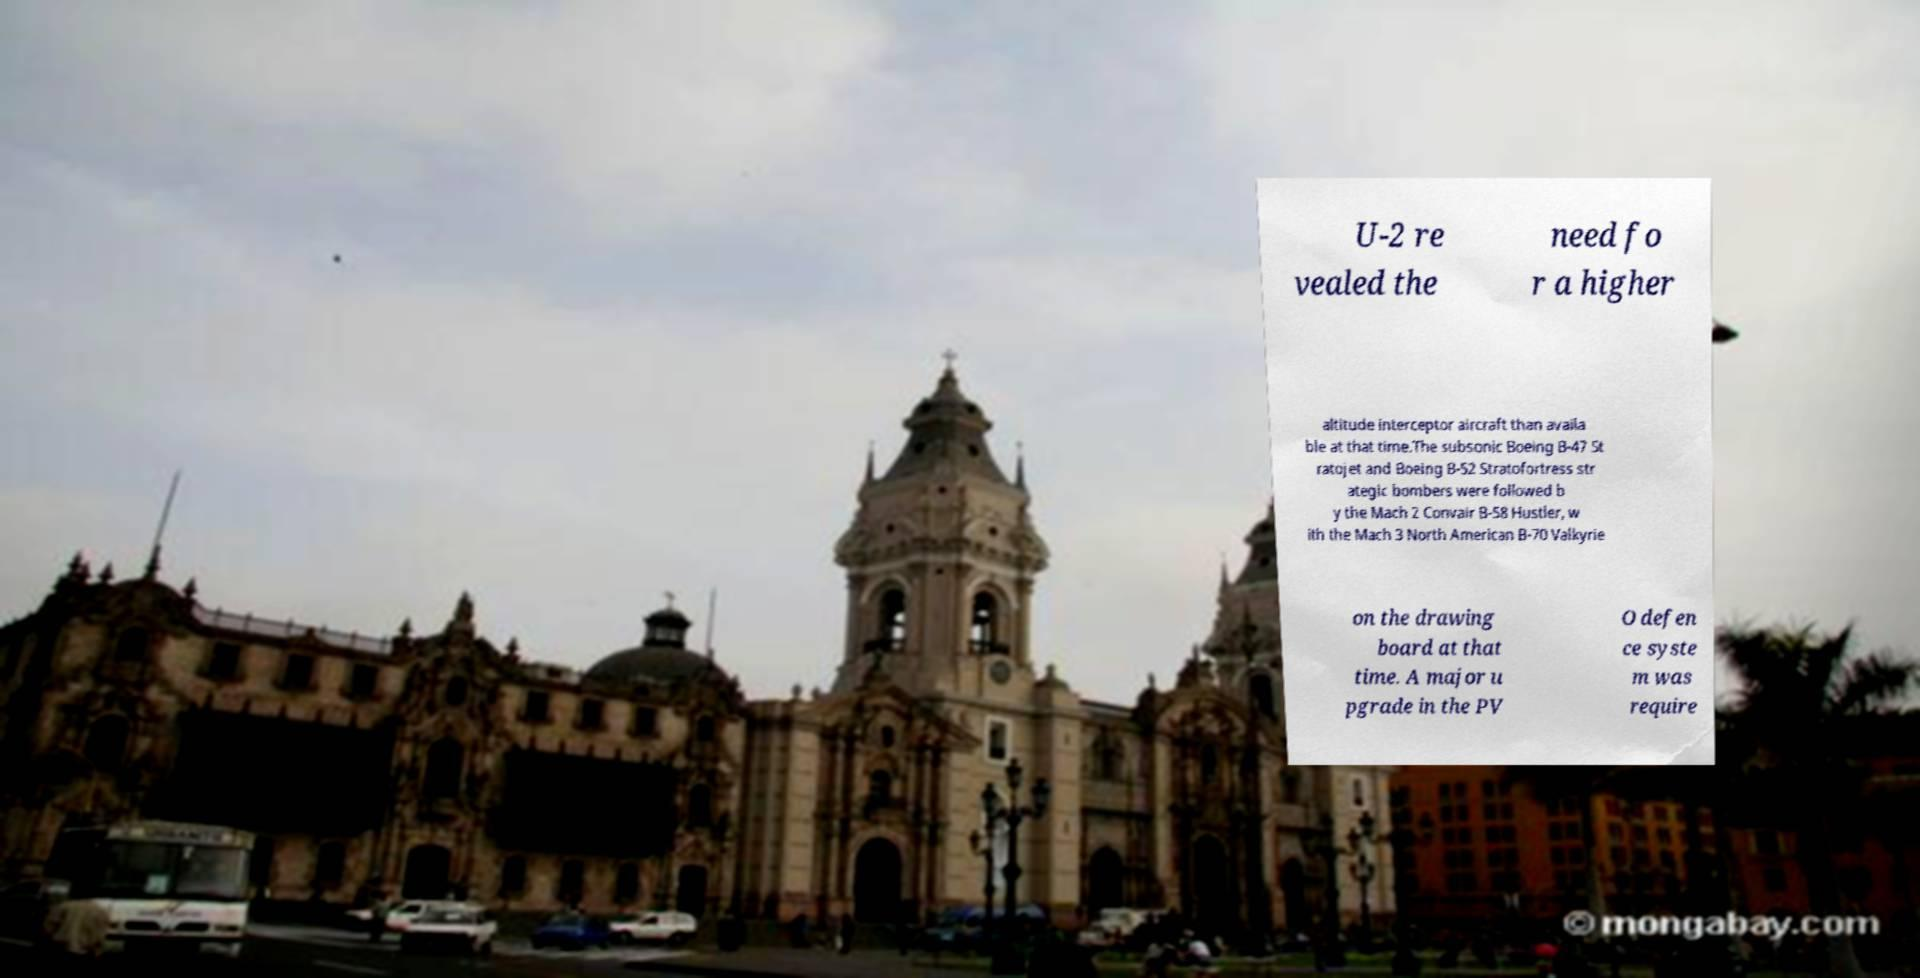Can you read and provide the text displayed in the image?This photo seems to have some interesting text. Can you extract and type it out for me? U-2 re vealed the need fo r a higher altitude interceptor aircraft than availa ble at that time.The subsonic Boeing B-47 St ratojet and Boeing B-52 Stratofortress str ategic bombers were followed b y the Mach 2 Convair B-58 Hustler, w ith the Mach 3 North American B-70 Valkyrie on the drawing board at that time. A major u pgrade in the PV O defen ce syste m was require 